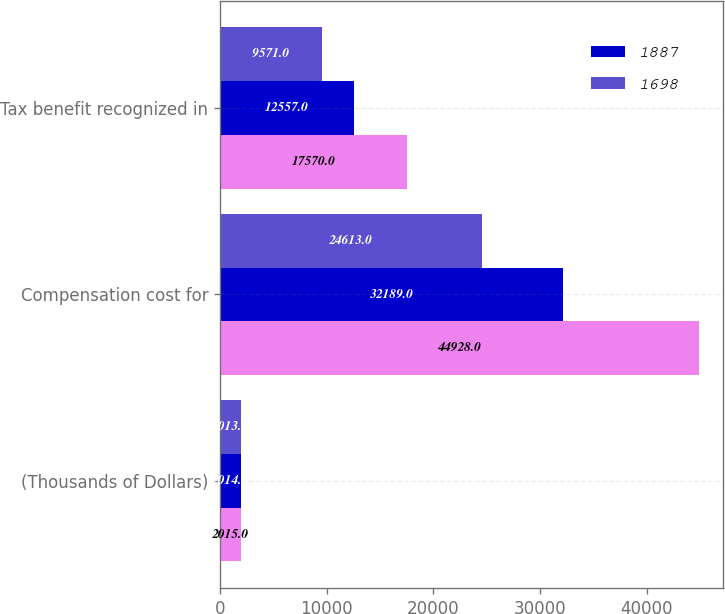<chart> <loc_0><loc_0><loc_500><loc_500><stacked_bar_chart><ecel><fcel>(Thousands of Dollars)<fcel>Compensation cost for<fcel>Tax benefit recognized in<nl><fcel>nan<fcel>2015<fcel>44928<fcel>17570<nl><fcel>1887<fcel>2014<fcel>32189<fcel>12557<nl><fcel>1698<fcel>2013<fcel>24613<fcel>9571<nl></chart> 